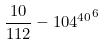<formula> <loc_0><loc_0><loc_500><loc_500>\frac { 1 0 } { 1 1 2 } - { 1 0 4 ^ { 4 0 } } ^ { 6 }</formula> 